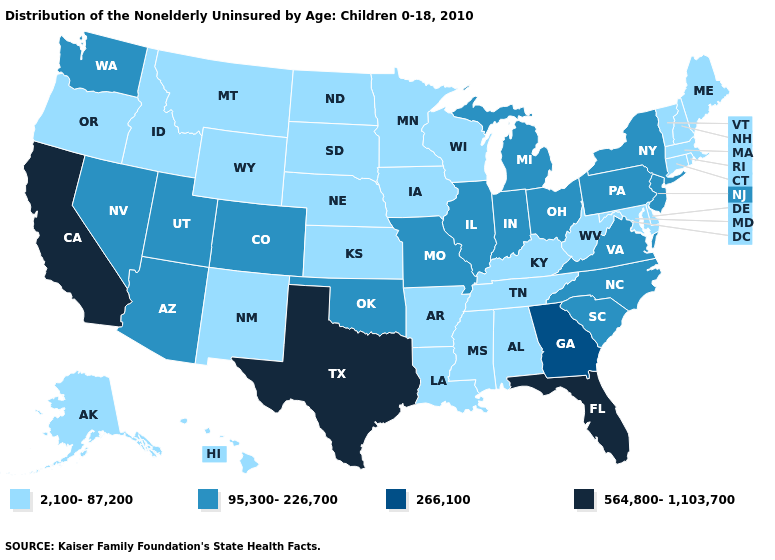What is the highest value in the USA?
Keep it brief. 564,800-1,103,700. What is the value of California?
Write a very short answer. 564,800-1,103,700. Does Pennsylvania have the lowest value in the Northeast?
Write a very short answer. No. Name the states that have a value in the range 564,800-1,103,700?
Short answer required. California, Florida, Texas. Among the states that border Connecticut , does New York have the lowest value?
Be succinct. No. What is the highest value in the USA?
Short answer required. 564,800-1,103,700. What is the value of Massachusetts?
Answer briefly. 2,100-87,200. Name the states that have a value in the range 2,100-87,200?
Concise answer only. Alabama, Alaska, Arkansas, Connecticut, Delaware, Hawaii, Idaho, Iowa, Kansas, Kentucky, Louisiana, Maine, Maryland, Massachusetts, Minnesota, Mississippi, Montana, Nebraska, New Hampshire, New Mexico, North Dakota, Oregon, Rhode Island, South Dakota, Tennessee, Vermont, West Virginia, Wisconsin, Wyoming. Does California have the same value as Florida?
Keep it brief. Yes. Name the states that have a value in the range 564,800-1,103,700?
Keep it brief. California, Florida, Texas. Does Iowa have the same value as West Virginia?
Keep it brief. Yes. What is the highest value in the USA?
Short answer required. 564,800-1,103,700. What is the value of Florida?
Be succinct. 564,800-1,103,700. Name the states that have a value in the range 95,300-226,700?
Give a very brief answer. Arizona, Colorado, Illinois, Indiana, Michigan, Missouri, Nevada, New Jersey, New York, North Carolina, Ohio, Oklahoma, Pennsylvania, South Carolina, Utah, Virginia, Washington. Which states have the lowest value in the USA?
Give a very brief answer. Alabama, Alaska, Arkansas, Connecticut, Delaware, Hawaii, Idaho, Iowa, Kansas, Kentucky, Louisiana, Maine, Maryland, Massachusetts, Minnesota, Mississippi, Montana, Nebraska, New Hampshire, New Mexico, North Dakota, Oregon, Rhode Island, South Dakota, Tennessee, Vermont, West Virginia, Wisconsin, Wyoming. 